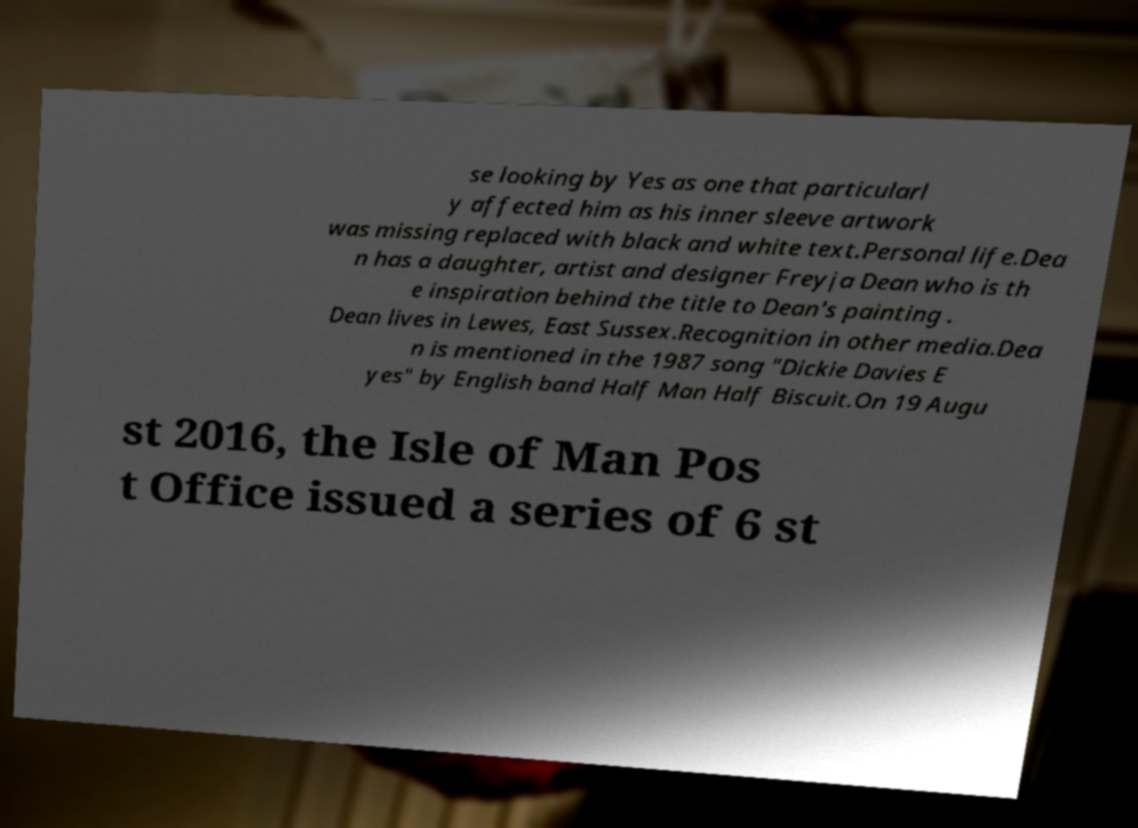Could you assist in decoding the text presented in this image and type it out clearly? se looking by Yes as one that particularl y affected him as his inner sleeve artwork was missing replaced with black and white text.Personal life.Dea n has a daughter, artist and designer Freyja Dean who is th e inspiration behind the title to Dean's painting . Dean lives in Lewes, East Sussex.Recognition in other media.Dea n is mentioned in the 1987 song "Dickie Davies E yes" by English band Half Man Half Biscuit.On 19 Augu st 2016, the Isle of Man Pos t Office issued a series of 6 st 